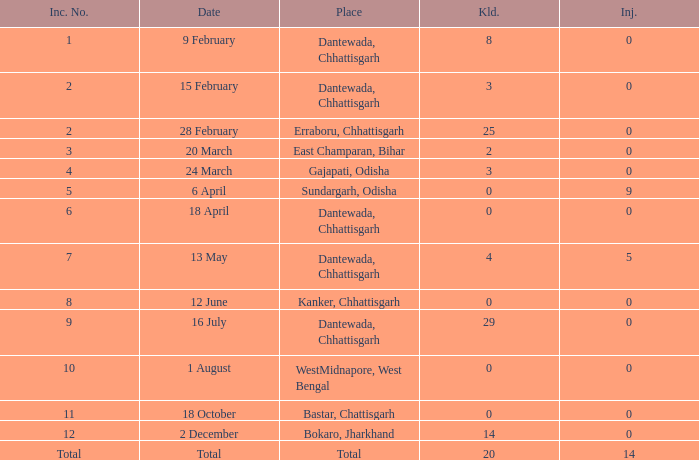How many people were injured in total in East Champaran, Bihar with more than 2 people killed? 0.0. 